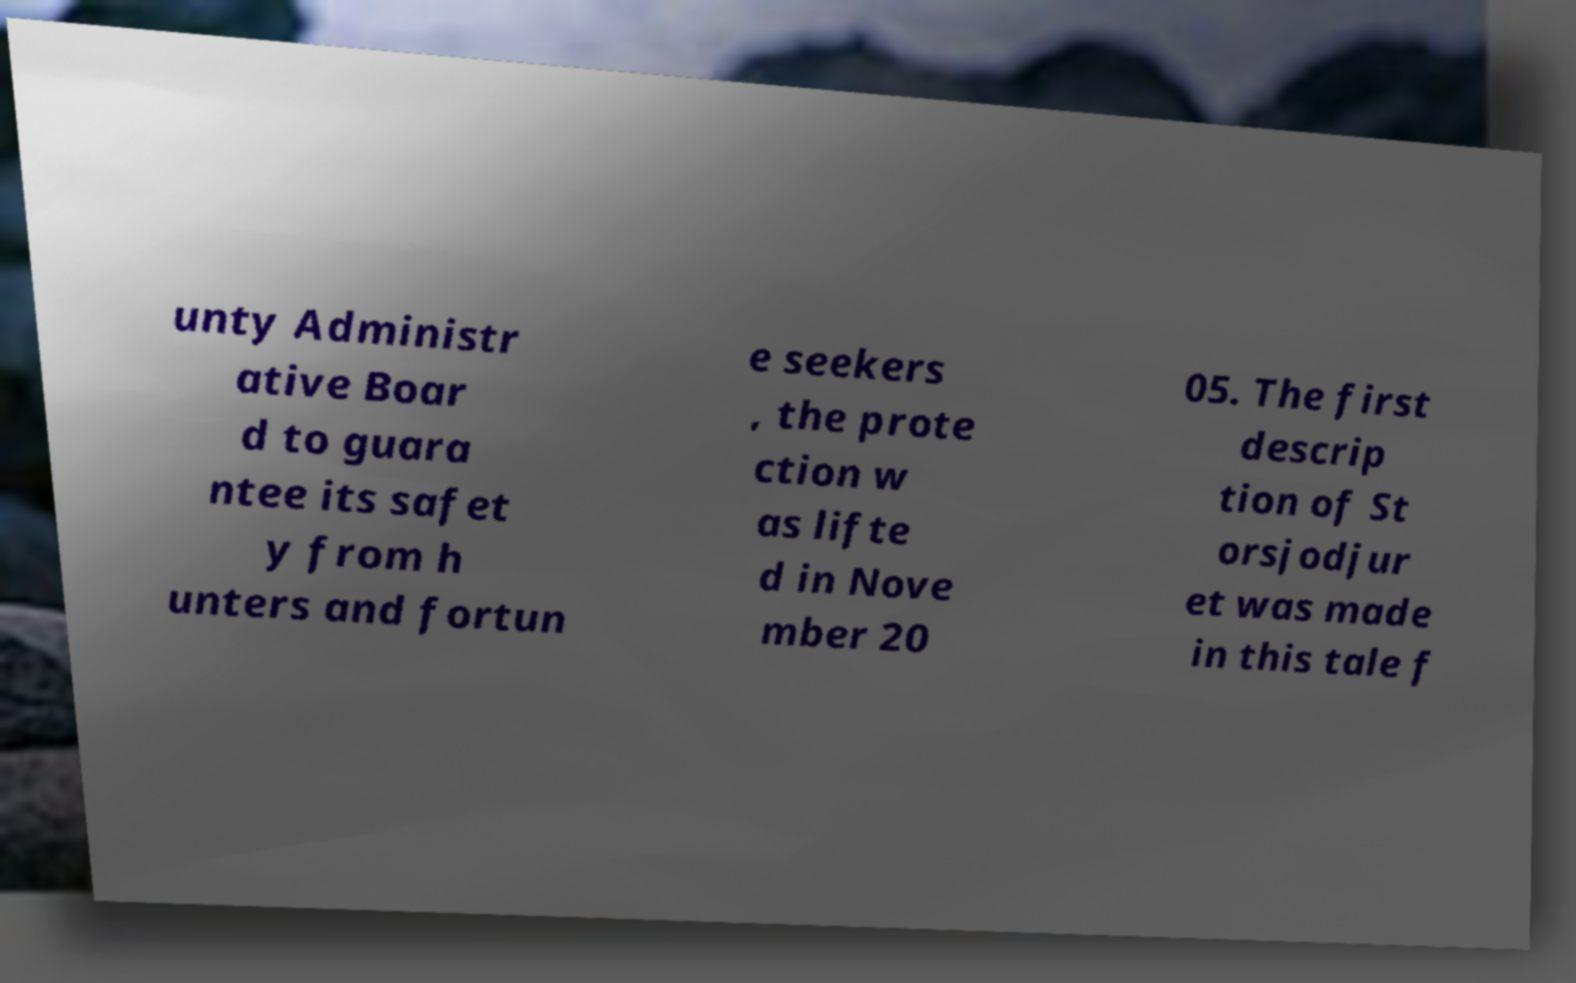There's text embedded in this image that I need extracted. Can you transcribe it verbatim? unty Administr ative Boar d to guara ntee its safet y from h unters and fortun e seekers , the prote ction w as lifte d in Nove mber 20 05. The first descrip tion of St orsjodjur et was made in this tale f 